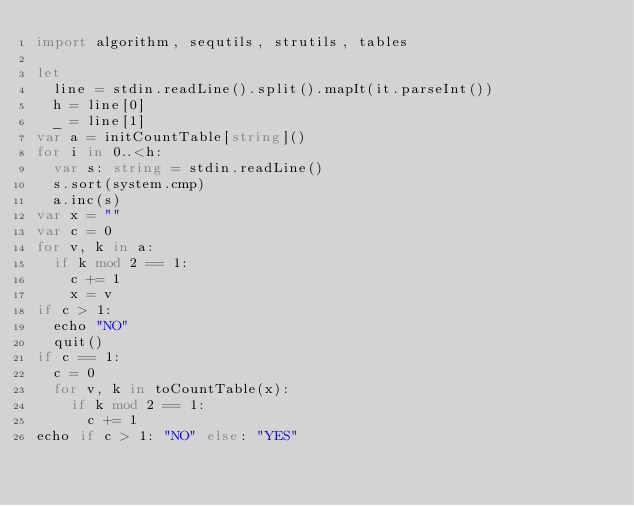Convert code to text. <code><loc_0><loc_0><loc_500><loc_500><_Nim_>import algorithm, sequtils, strutils, tables

let
  line = stdin.readLine().split().mapIt(it.parseInt())
  h = line[0]
  _ = line[1]
var a = initCountTable[string]()
for i in 0..<h:
  var s: string = stdin.readLine()
  s.sort(system.cmp)
  a.inc(s)
var x = ""
var c = 0
for v, k in a:
  if k mod 2 == 1:
    c += 1
    x = v
if c > 1:
  echo "NO"
  quit()
if c == 1:
  c = 0
  for v, k in toCountTable(x):
    if k mod 2 == 1:
      c += 1
echo if c > 1: "NO" else: "YES"
</code> 